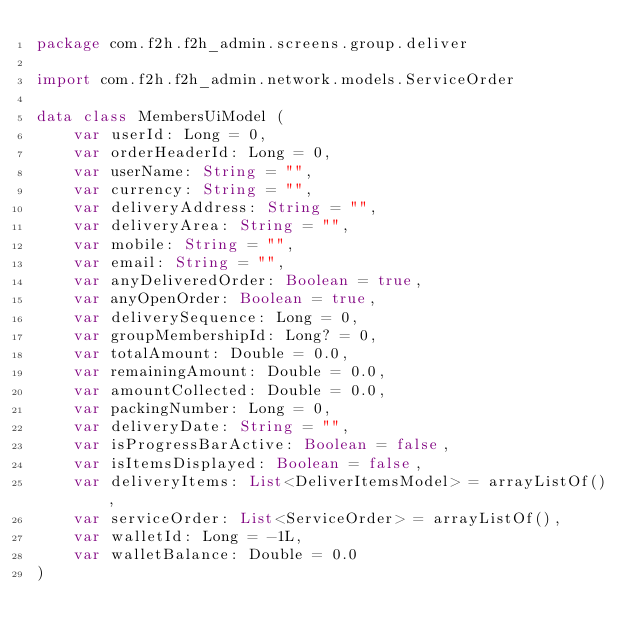<code> <loc_0><loc_0><loc_500><loc_500><_Kotlin_>package com.f2h.f2h_admin.screens.group.deliver

import com.f2h.f2h_admin.network.models.ServiceOrder

data class MembersUiModel (
    var userId: Long = 0,
    var orderHeaderId: Long = 0,
    var userName: String = "",
    var currency: String = "",
    var deliveryAddress: String = "",
    var deliveryArea: String = "",
    var mobile: String = "",
    var email: String = "",
    var anyDeliveredOrder: Boolean = true,
    var anyOpenOrder: Boolean = true,
    var deliverySequence: Long = 0,
    var groupMembershipId: Long? = 0,
    var totalAmount: Double = 0.0,
    var remainingAmount: Double = 0.0,
    var amountCollected: Double = 0.0,
    var packingNumber: Long = 0,
    var deliveryDate: String = "",
    var isProgressBarActive: Boolean = false,
    var isItemsDisplayed: Boolean = false,
    var deliveryItems: List<DeliverItemsModel> = arrayListOf(),
    var serviceOrder: List<ServiceOrder> = arrayListOf(),
    var walletId: Long = -1L,
    var walletBalance: Double = 0.0
)
</code> 